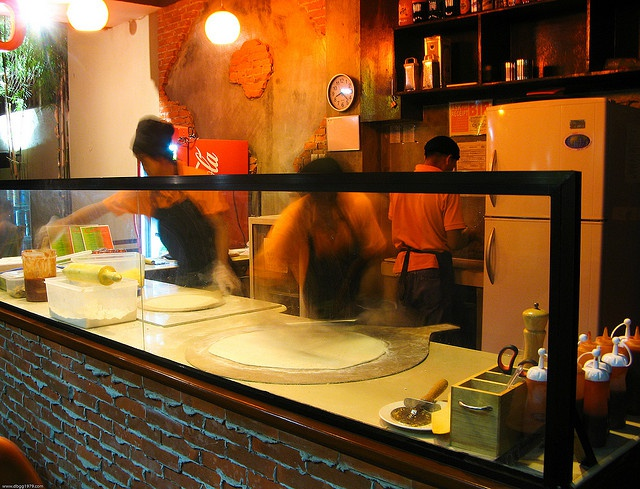Describe the objects in this image and their specific colors. I can see refrigerator in salmon, black, orange, and brown tones, people in salmon, black, maroon, and red tones, people in salmon, black, brown, maroon, and red tones, people in salmon, black, brown, maroon, and red tones, and refrigerator in salmon, red, maroon, and black tones in this image. 